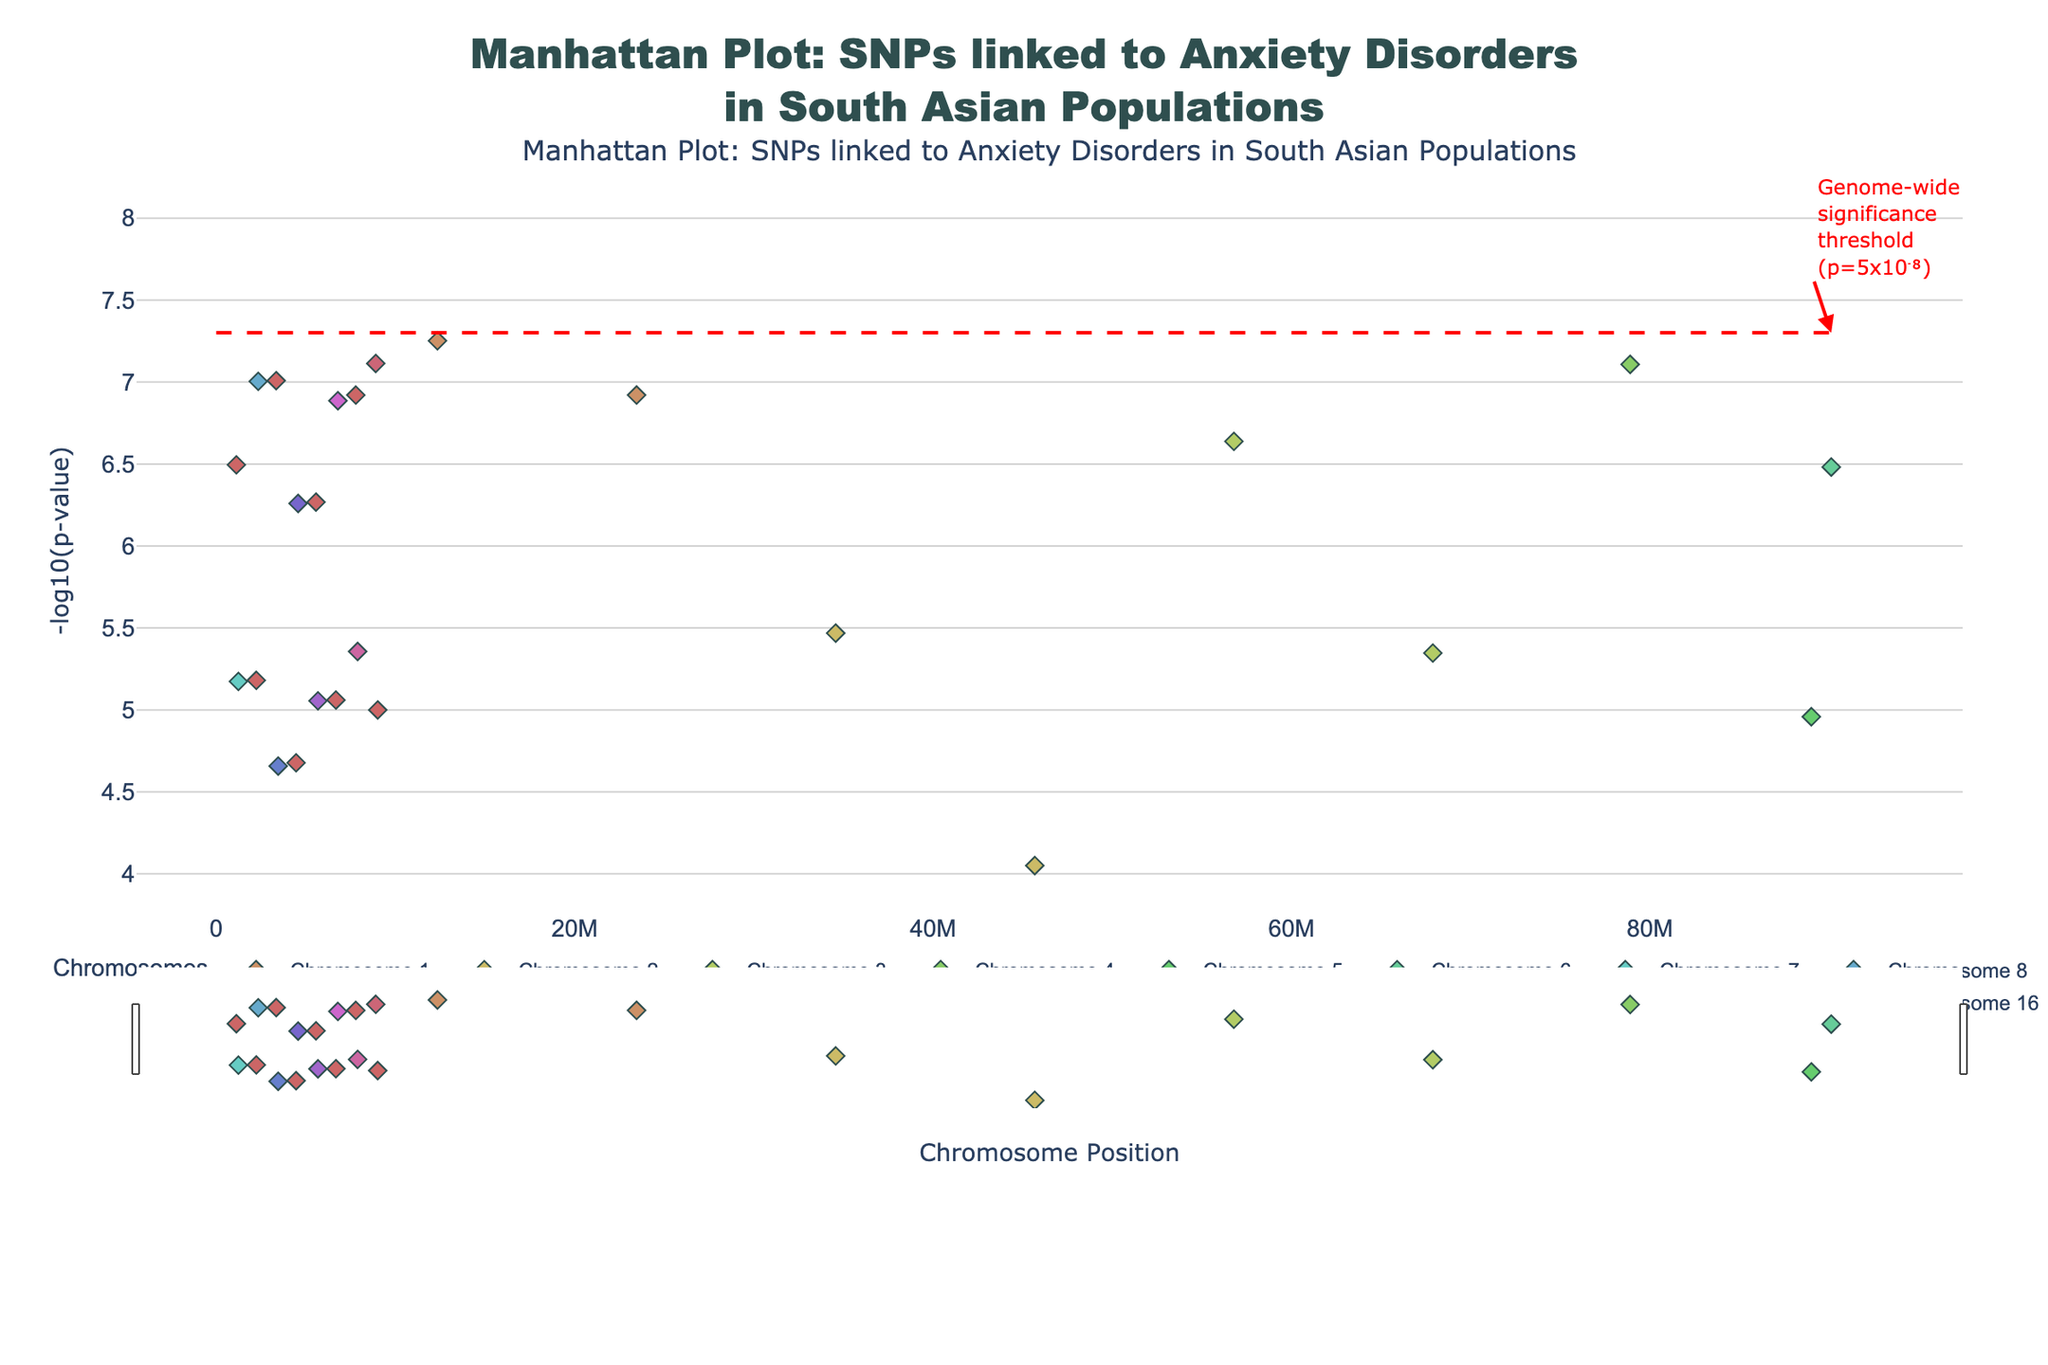What is the full title of the Manhattan Plot? The title is displayed prominently at the top of the figure. It reads "Manhattan Plot: SNPs linked to Anxiety Disorders in South Asian Populations".
Answer: Manhattan Plot: SNPs linked to Anxiety Disorders in South Asian Populations How many chromosomes are represented in the plot? Each unique chromosome is indicated by the color-coded legends and separate scatter traces. The plot includes Chromosomes 1 through 22.
Answer: 22 Which SNP has the lowest p-value? The lowest p-value corresponds to the highest -log10(p-value) on the y-axis. By identifying the highest point on the plot, we find SNP rs1234567 on Chromosome 8.
Answer: rs1234567 What does the red dashed line represent? The red dashed line across the plot marks the genome-wide significance threshold, indicating where p-values are equal to 5x10⁻⁸, as stated by the annotation beside the line.
Answer: Genome-wide significance threshold (p=5x10⁻⁸) Compare the -log10(p-values) of the SNPs on Chromosome 1. Which one is higher, rs1234567 at position 12345678 or rs2345678 at position 23456789? Look at the y-values for positions 12345678 and 23456789 on Chromosome 1. SNP rs1234567 has a higher -log10(p-value) than rs2345678.
Answer: rs1234567 How many SNPs are above the genome-wide significance threshold? Count the data points that are above the red dashed line which marks -log10(5x10⁻⁸). There are three SNPs above this threshold: rs1234567 on Chromosome 1, and rs7890123 and rs1123456 on Chromosome 3 and 8 respectively.
Answer: 3 What is the highest -log10(p-value) recorded in the plot? Identify the tallest point of the figure, which corresponds to the maximum -log10(p-value). This appears at y-axis location just above 7.
Answer: ~7.004 Which chromosome has the SNPs with the highest cumulative -log10(p-value)? Accumulate the height of the points for each chromosome to determine which chromosome has the highest sum of -log10(p-values). Chromosome 1 has the two points with very high -log10(p-values), contributing significantly.
Answer: Chromosome 1 What is typical about the distribution of SNPs across chromosomes in terms of p-values? Analyze the distribution of y-values (log10(p-values)) for each chromosome. Typically, there are scattered and mostly lower p-values, with a few points significantly above the threshold, suggesting fewer highly significant SNPs.
Answer: Scattered distribution with few significant peaks Which SNP on Chromosome 10 has the most significant association with anxiety disorders based on p-value? Identify the data point with the highest -log10(p-value) on Chromosome 10's scatter plot. This corresponds to SNP rs1345678.
Answer: rs1345678 